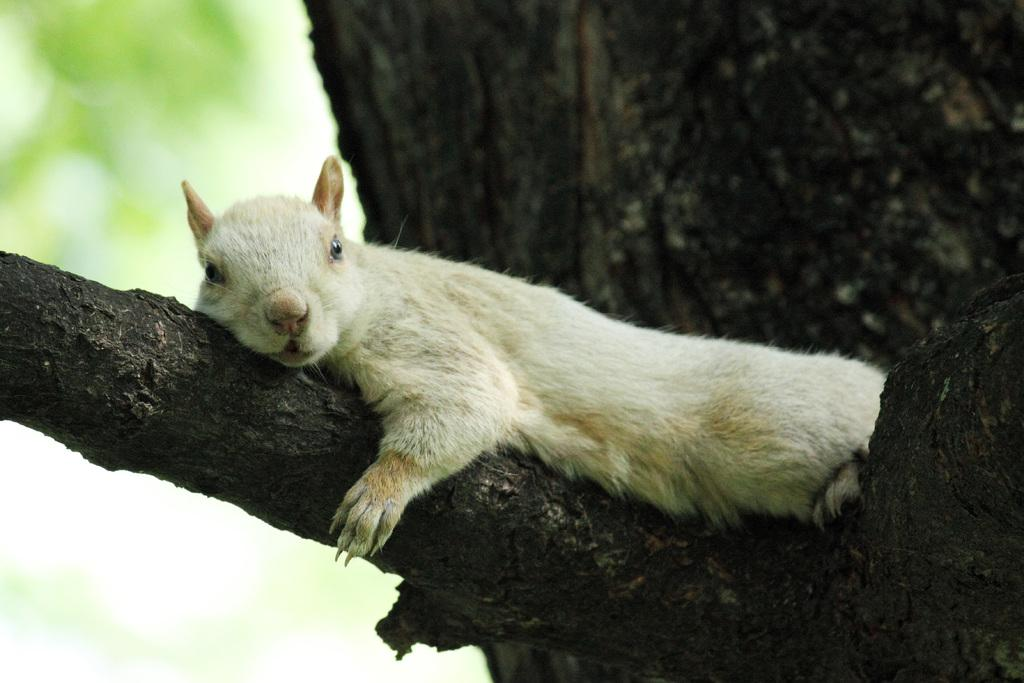What type of animal can be seen in the image? There is an animal in the image, but its specific type cannot be determined from the provided facts. Where is the animal located in the image? The animal is lying on a branch of a tree. What can be said about the background of the image? The background of the image is blurred. What type of linen is draped over the animal in the image? There is no linen present in the image; the animal is lying on a branch of a tree. How does the shock affect the animal in the image? There is no mention of a shock or any emotional state in the image; the animal is simply lying on a branch of a tree. 